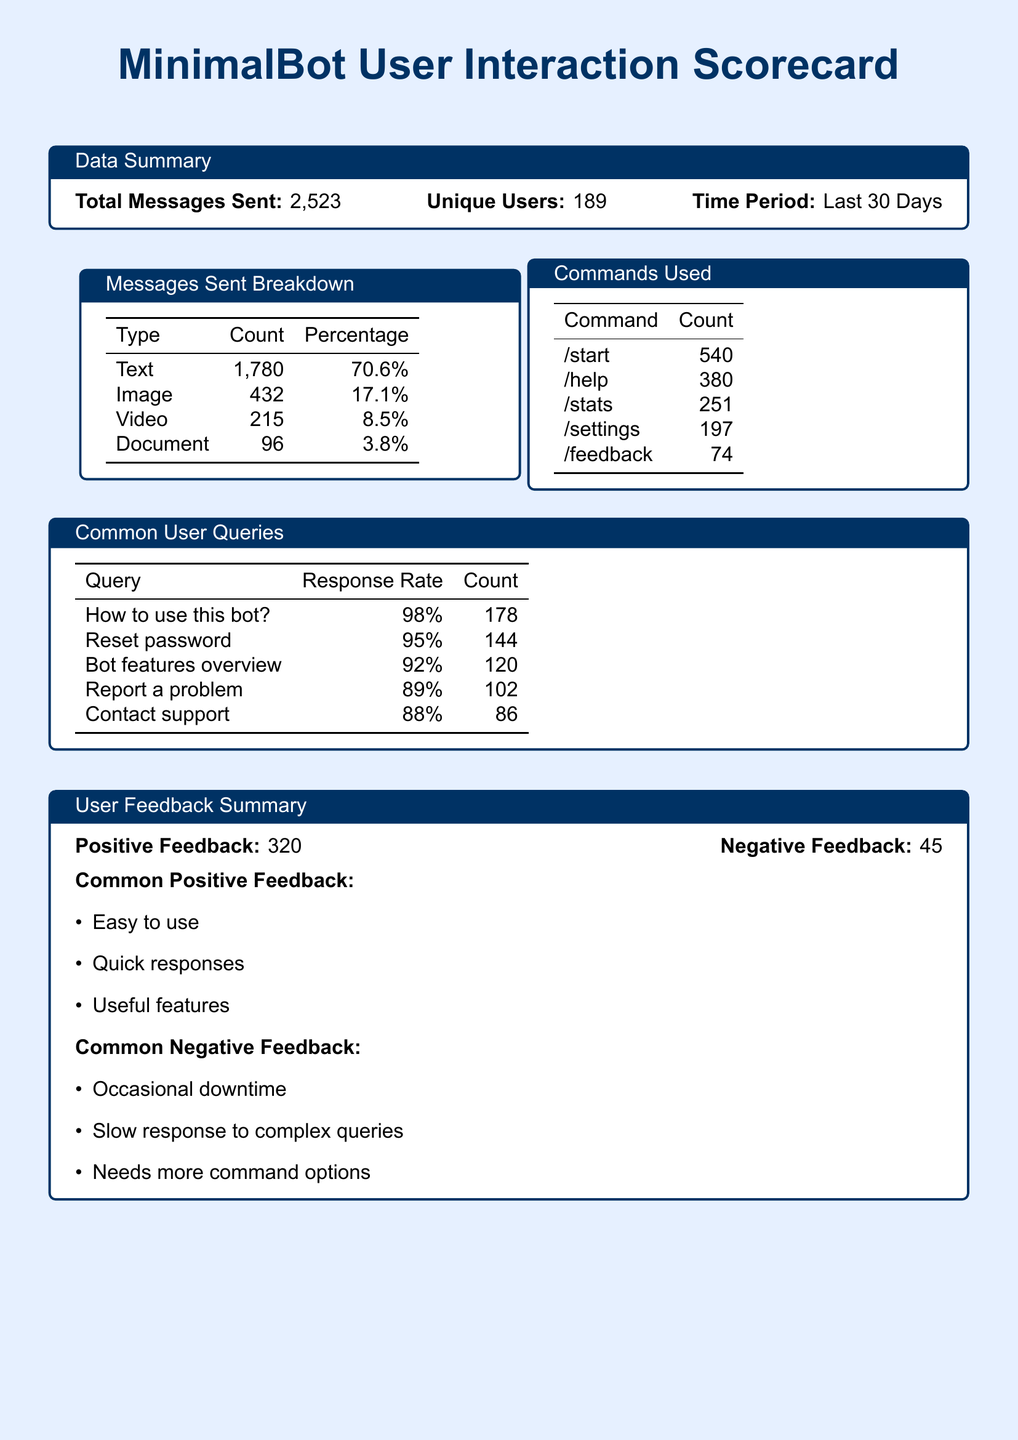What is the total number of unique users? The total number of unique users is stated in the data summary section of the document.
Answer: 189 How many text messages were sent? The number of text messages sent is shown in the messages sent breakdown table.
Answer: 1,780 Which command was used the most? The command usage table lists commands in order of frequency, highlighting the most used command.
Answer: /start What was the response rate for the query "Contact support"? The common user queries table includes the response rate for each query, including "Contact support."
Answer: 88% What percentage of messages were images? The percentage of image messages is calculated based on the messages sent breakdown.
Answer: 17.1% How many pieces of negative feedback were recorded? The user feedback summary explicitly states the total negative feedback received.
Answer: 45 Which query had the highest count in the common user queries? The common user queries table shows the count of each query, allowing for comparison to find the highest.
Answer: How to use this bot? What is the total count of commands used? By summing the counts of all commands in the commands used table, we can find the total count.
Answer: 1,442 What are the common themes in positive feedback? The user feedback summary lists common positive feedback themes.
Answer: Easy to use, Quick responses, Useful features 